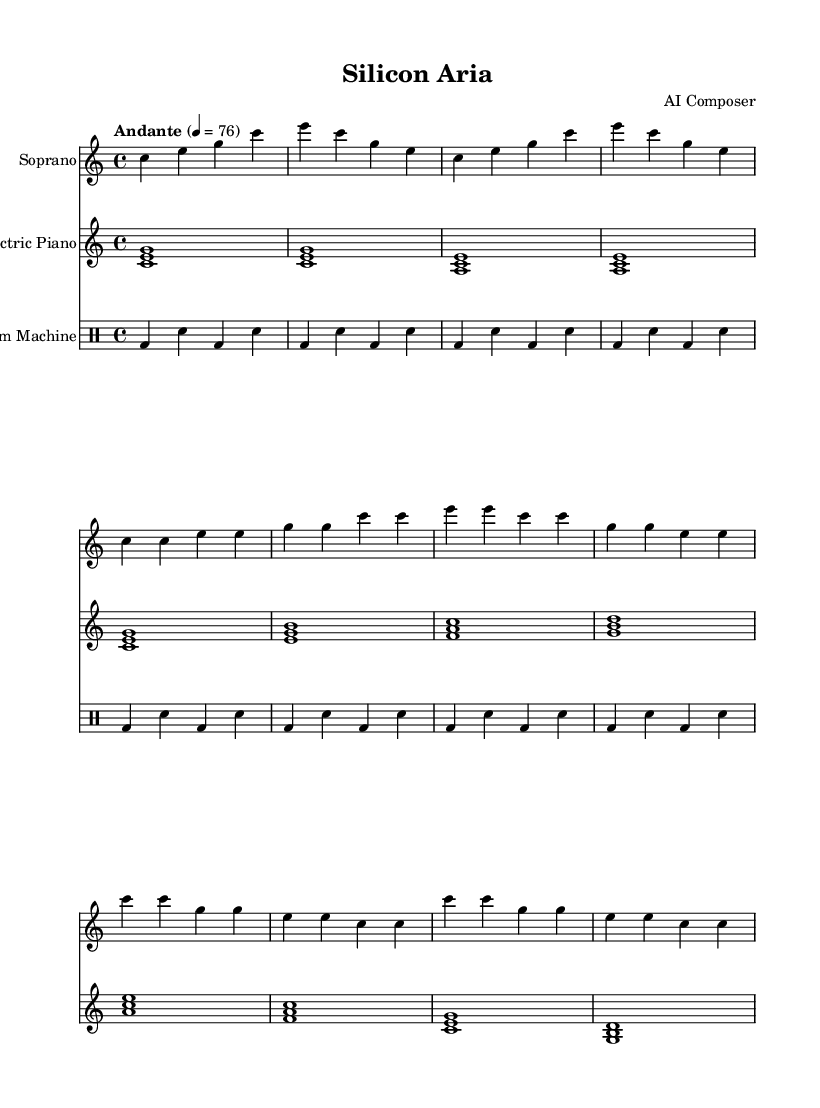What is the key signature of this music? The key signature is indicated at the beginning of the sheet music, and it shows there are no sharps or flats, which denotes the key of C major.
Answer: C major What is the time signature of the piece? The time signature is represented at the start of the score. It shows how many beats are in each measure, in this case, it is 4/4, indicating 4 beats per measure.
Answer: 4/4 What is the tempo marking of the composition? The tempo marking is found at the beginning, stating "Andante" and followed by a metronome mark of 76, which indicates a moderate pace.
Answer: Andante, 76 How many measures are in the verse section? By counting the measures in the verse from the provided music, there are 8 measures defined under the verse section.
Answer: 8 What is the primary thematic lyric in the chorus? The lyrics in the chorus are repeated lines that encapsulate the primary theme, which focuses on coding actions: "Compile, debug, refactor, repeat."
Answer: Compile, debug, refactor, repeat Which instruments are used in this opera piece? By observing the score, it lists three different instruments: Soprano, Electric Piano, and Drum Machine, indicating a combination of vocal and electronic components.
Answer: Soprano, Electric Piano, Drum Machine What type of opera style does this composition represent? This composition combines classical operatic elements with modern electronic music influences, making it a representative of minimalist opera that focuses on repetitive structures for coding sessions.
Answer: Minimalist opera with electronic influences 